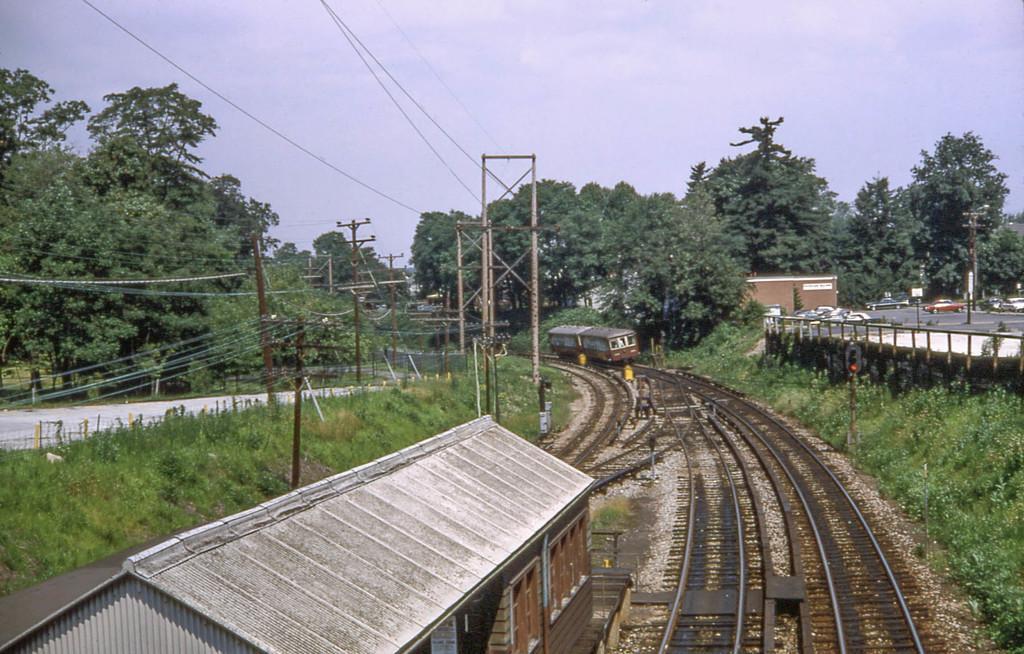Please provide a concise description of this image. In the foreground of this image, there is roof of a shelter and the tracks. On either side there is greenery. On the left, there is path, poles, cables, trees and the sky. On the right, there are vehicles on the road, few poles, trees and buildings. In the background, we can see few compartments on the track, trees and the sky. 